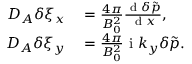<formula> <loc_0><loc_0><loc_500><loc_500>\begin{array} { r l } { D _ { A } \delta \xi _ { x } } & = \frac { 4 \pi } { B _ { 0 } ^ { 2 } } \frac { d \delta \tilde { p } } { d x } , } \\ { D _ { A } \delta \xi _ { y } } & = \frac { 4 \pi } { B _ { 0 } ^ { 2 } } i k _ { y } \delta \tilde { p } . } \end{array}</formula> 